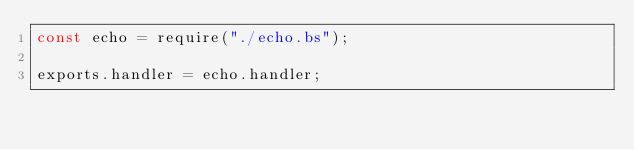<code> <loc_0><loc_0><loc_500><loc_500><_JavaScript_>const echo = require("./echo.bs");

exports.handler = echo.handler;
</code> 